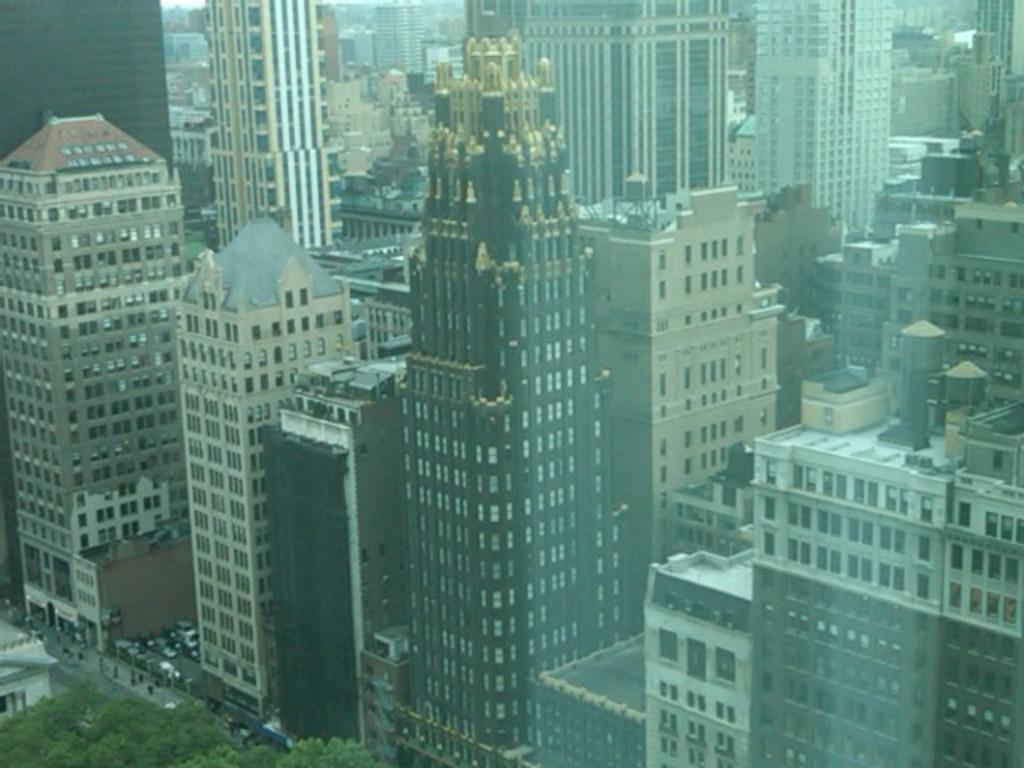Can you describe this image briefly? In this image I can see buildings and in the bottom left I can see trees. 